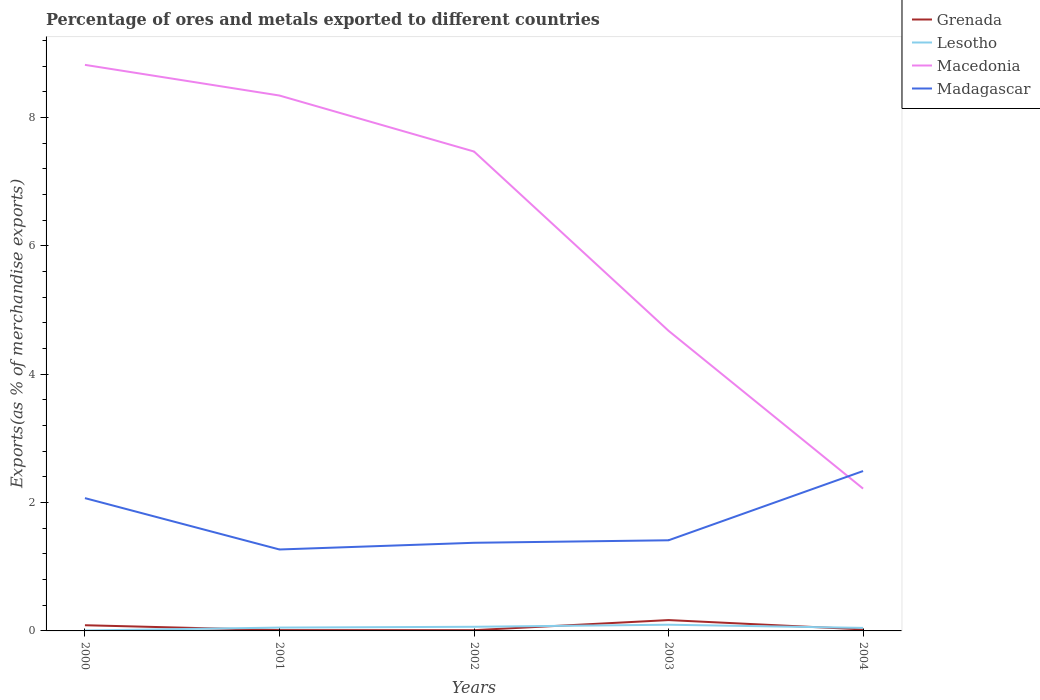How many different coloured lines are there?
Give a very brief answer. 4. Is the number of lines equal to the number of legend labels?
Your answer should be compact. Yes. Across all years, what is the maximum percentage of exports to different countries in Madagascar?
Make the answer very short. 1.27. In which year was the percentage of exports to different countries in Lesotho maximum?
Your answer should be very brief. 2000. What is the total percentage of exports to different countries in Madagascar in the graph?
Offer a very short reply. -1.12. What is the difference between the highest and the second highest percentage of exports to different countries in Grenada?
Your answer should be very brief. 0.16. What is the difference between the highest and the lowest percentage of exports to different countries in Grenada?
Your answer should be compact. 2. What is the difference between two consecutive major ticks on the Y-axis?
Make the answer very short. 2. Are the values on the major ticks of Y-axis written in scientific E-notation?
Keep it short and to the point. No. Does the graph contain any zero values?
Offer a terse response. No. Where does the legend appear in the graph?
Offer a terse response. Top right. How are the legend labels stacked?
Offer a terse response. Vertical. What is the title of the graph?
Give a very brief answer. Percentage of ores and metals exported to different countries. Does "Nicaragua" appear as one of the legend labels in the graph?
Make the answer very short. No. What is the label or title of the X-axis?
Provide a succinct answer. Years. What is the label or title of the Y-axis?
Your answer should be compact. Exports(as % of merchandise exports). What is the Exports(as % of merchandise exports) of Grenada in 2000?
Provide a succinct answer. 0.09. What is the Exports(as % of merchandise exports) of Lesotho in 2000?
Provide a succinct answer. 0.01. What is the Exports(as % of merchandise exports) of Macedonia in 2000?
Give a very brief answer. 8.82. What is the Exports(as % of merchandise exports) of Madagascar in 2000?
Provide a short and direct response. 2.07. What is the Exports(as % of merchandise exports) in Grenada in 2001?
Keep it short and to the point. 0.01. What is the Exports(as % of merchandise exports) in Lesotho in 2001?
Your response must be concise. 0.05. What is the Exports(as % of merchandise exports) in Macedonia in 2001?
Your answer should be compact. 8.34. What is the Exports(as % of merchandise exports) in Madagascar in 2001?
Provide a short and direct response. 1.27. What is the Exports(as % of merchandise exports) in Grenada in 2002?
Ensure brevity in your answer.  0.01. What is the Exports(as % of merchandise exports) in Lesotho in 2002?
Your answer should be very brief. 0.06. What is the Exports(as % of merchandise exports) in Macedonia in 2002?
Your response must be concise. 7.47. What is the Exports(as % of merchandise exports) in Madagascar in 2002?
Offer a terse response. 1.37. What is the Exports(as % of merchandise exports) of Grenada in 2003?
Your answer should be very brief. 0.17. What is the Exports(as % of merchandise exports) in Lesotho in 2003?
Your response must be concise. 0.1. What is the Exports(as % of merchandise exports) of Macedonia in 2003?
Provide a short and direct response. 4.68. What is the Exports(as % of merchandise exports) of Madagascar in 2003?
Ensure brevity in your answer.  1.41. What is the Exports(as % of merchandise exports) of Grenada in 2004?
Offer a terse response. 0.02. What is the Exports(as % of merchandise exports) in Lesotho in 2004?
Keep it short and to the point. 0.05. What is the Exports(as % of merchandise exports) of Macedonia in 2004?
Your answer should be very brief. 2.22. What is the Exports(as % of merchandise exports) in Madagascar in 2004?
Your answer should be very brief. 2.49. Across all years, what is the maximum Exports(as % of merchandise exports) of Grenada?
Make the answer very short. 0.17. Across all years, what is the maximum Exports(as % of merchandise exports) of Lesotho?
Give a very brief answer. 0.1. Across all years, what is the maximum Exports(as % of merchandise exports) of Macedonia?
Your response must be concise. 8.82. Across all years, what is the maximum Exports(as % of merchandise exports) of Madagascar?
Give a very brief answer. 2.49. Across all years, what is the minimum Exports(as % of merchandise exports) in Grenada?
Give a very brief answer. 0.01. Across all years, what is the minimum Exports(as % of merchandise exports) of Lesotho?
Give a very brief answer. 0.01. Across all years, what is the minimum Exports(as % of merchandise exports) in Macedonia?
Your response must be concise. 2.22. Across all years, what is the minimum Exports(as % of merchandise exports) in Madagascar?
Your answer should be very brief. 1.27. What is the total Exports(as % of merchandise exports) in Grenada in the graph?
Give a very brief answer. 0.31. What is the total Exports(as % of merchandise exports) in Lesotho in the graph?
Ensure brevity in your answer.  0.27. What is the total Exports(as % of merchandise exports) in Macedonia in the graph?
Give a very brief answer. 31.53. What is the total Exports(as % of merchandise exports) of Madagascar in the graph?
Your response must be concise. 8.61. What is the difference between the Exports(as % of merchandise exports) of Grenada in 2000 and that in 2001?
Provide a succinct answer. 0.08. What is the difference between the Exports(as % of merchandise exports) in Lesotho in 2000 and that in 2001?
Make the answer very short. -0.05. What is the difference between the Exports(as % of merchandise exports) in Macedonia in 2000 and that in 2001?
Your answer should be compact. 0.48. What is the difference between the Exports(as % of merchandise exports) of Madagascar in 2000 and that in 2001?
Keep it short and to the point. 0.8. What is the difference between the Exports(as % of merchandise exports) of Grenada in 2000 and that in 2002?
Your answer should be compact. 0.08. What is the difference between the Exports(as % of merchandise exports) in Lesotho in 2000 and that in 2002?
Ensure brevity in your answer.  -0.06. What is the difference between the Exports(as % of merchandise exports) of Macedonia in 2000 and that in 2002?
Give a very brief answer. 1.35. What is the difference between the Exports(as % of merchandise exports) in Madagascar in 2000 and that in 2002?
Provide a short and direct response. 0.7. What is the difference between the Exports(as % of merchandise exports) in Grenada in 2000 and that in 2003?
Provide a short and direct response. -0.08. What is the difference between the Exports(as % of merchandise exports) in Lesotho in 2000 and that in 2003?
Your answer should be very brief. -0.09. What is the difference between the Exports(as % of merchandise exports) of Macedonia in 2000 and that in 2003?
Give a very brief answer. 4.14. What is the difference between the Exports(as % of merchandise exports) in Madagascar in 2000 and that in 2003?
Your answer should be compact. 0.66. What is the difference between the Exports(as % of merchandise exports) of Grenada in 2000 and that in 2004?
Keep it short and to the point. 0.07. What is the difference between the Exports(as % of merchandise exports) in Lesotho in 2000 and that in 2004?
Ensure brevity in your answer.  -0.04. What is the difference between the Exports(as % of merchandise exports) of Macedonia in 2000 and that in 2004?
Make the answer very short. 6.6. What is the difference between the Exports(as % of merchandise exports) in Madagascar in 2000 and that in 2004?
Provide a short and direct response. -0.42. What is the difference between the Exports(as % of merchandise exports) in Grenada in 2001 and that in 2002?
Keep it short and to the point. 0. What is the difference between the Exports(as % of merchandise exports) in Lesotho in 2001 and that in 2002?
Offer a terse response. -0.01. What is the difference between the Exports(as % of merchandise exports) in Macedonia in 2001 and that in 2002?
Your response must be concise. 0.87. What is the difference between the Exports(as % of merchandise exports) of Madagascar in 2001 and that in 2002?
Provide a short and direct response. -0.1. What is the difference between the Exports(as % of merchandise exports) of Grenada in 2001 and that in 2003?
Offer a terse response. -0.16. What is the difference between the Exports(as % of merchandise exports) in Lesotho in 2001 and that in 2003?
Provide a short and direct response. -0.04. What is the difference between the Exports(as % of merchandise exports) of Macedonia in 2001 and that in 2003?
Your answer should be very brief. 3.67. What is the difference between the Exports(as % of merchandise exports) of Madagascar in 2001 and that in 2003?
Keep it short and to the point. -0.14. What is the difference between the Exports(as % of merchandise exports) of Grenada in 2001 and that in 2004?
Give a very brief answer. -0.01. What is the difference between the Exports(as % of merchandise exports) of Lesotho in 2001 and that in 2004?
Your answer should be very brief. 0. What is the difference between the Exports(as % of merchandise exports) in Macedonia in 2001 and that in 2004?
Your answer should be very brief. 6.12. What is the difference between the Exports(as % of merchandise exports) of Madagascar in 2001 and that in 2004?
Provide a succinct answer. -1.22. What is the difference between the Exports(as % of merchandise exports) of Grenada in 2002 and that in 2003?
Your answer should be compact. -0.16. What is the difference between the Exports(as % of merchandise exports) in Lesotho in 2002 and that in 2003?
Provide a succinct answer. -0.03. What is the difference between the Exports(as % of merchandise exports) in Macedonia in 2002 and that in 2003?
Your answer should be very brief. 2.79. What is the difference between the Exports(as % of merchandise exports) of Madagascar in 2002 and that in 2003?
Provide a short and direct response. -0.04. What is the difference between the Exports(as % of merchandise exports) in Grenada in 2002 and that in 2004?
Offer a terse response. -0.01. What is the difference between the Exports(as % of merchandise exports) in Lesotho in 2002 and that in 2004?
Your response must be concise. 0.02. What is the difference between the Exports(as % of merchandise exports) in Macedonia in 2002 and that in 2004?
Your response must be concise. 5.25. What is the difference between the Exports(as % of merchandise exports) of Madagascar in 2002 and that in 2004?
Offer a terse response. -1.12. What is the difference between the Exports(as % of merchandise exports) of Grenada in 2003 and that in 2004?
Your response must be concise. 0.15. What is the difference between the Exports(as % of merchandise exports) of Lesotho in 2003 and that in 2004?
Offer a terse response. 0.05. What is the difference between the Exports(as % of merchandise exports) of Macedonia in 2003 and that in 2004?
Make the answer very short. 2.46. What is the difference between the Exports(as % of merchandise exports) of Madagascar in 2003 and that in 2004?
Keep it short and to the point. -1.08. What is the difference between the Exports(as % of merchandise exports) in Grenada in 2000 and the Exports(as % of merchandise exports) in Lesotho in 2001?
Offer a terse response. 0.04. What is the difference between the Exports(as % of merchandise exports) in Grenada in 2000 and the Exports(as % of merchandise exports) in Macedonia in 2001?
Keep it short and to the point. -8.25. What is the difference between the Exports(as % of merchandise exports) in Grenada in 2000 and the Exports(as % of merchandise exports) in Madagascar in 2001?
Provide a succinct answer. -1.18. What is the difference between the Exports(as % of merchandise exports) of Lesotho in 2000 and the Exports(as % of merchandise exports) of Macedonia in 2001?
Offer a terse response. -8.34. What is the difference between the Exports(as % of merchandise exports) in Lesotho in 2000 and the Exports(as % of merchandise exports) in Madagascar in 2001?
Give a very brief answer. -1.26. What is the difference between the Exports(as % of merchandise exports) in Macedonia in 2000 and the Exports(as % of merchandise exports) in Madagascar in 2001?
Your response must be concise. 7.55. What is the difference between the Exports(as % of merchandise exports) in Grenada in 2000 and the Exports(as % of merchandise exports) in Lesotho in 2002?
Keep it short and to the point. 0.02. What is the difference between the Exports(as % of merchandise exports) of Grenada in 2000 and the Exports(as % of merchandise exports) of Macedonia in 2002?
Offer a very short reply. -7.38. What is the difference between the Exports(as % of merchandise exports) in Grenada in 2000 and the Exports(as % of merchandise exports) in Madagascar in 2002?
Provide a short and direct response. -1.28. What is the difference between the Exports(as % of merchandise exports) in Lesotho in 2000 and the Exports(as % of merchandise exports) in Macedonia in 2002?
Provide a succinct answer. -7.46. What is the difference between the Exports(as % of merchandise exports) in Lesotho in 2000 and the Exports(as % of merchandise exports) in Madagascar in 2002?
Your answer should be very brief. -1.37. What is the difference between the Exports(as % of merchandise exports) of Macedonia in 2000 and the Exports(as % of merchandise exports) of Madagascar in 2002?
Your answer should be very brief. 7.45. What is the difference between the Exports(as % of merchandise exports) of Grenada in 2000 and the Exports(as % of merchandise exports) of Lesotho in 2003?
Offer a very short reply. -0.01. What is the difference between the Exports(as % of merchandise exports) of Grenada in 2000 and the Exports(as % of merchandise exports) of Macedonia in 2003?
Give a very brief answer. -4.59. What is the difference between the Exports(as % of merchandise exports) in Grenada in 2000 and the Exports(as % of merchandise exports) in Madagascar in 2003?
Keep it short and to the point. -1.32. What is the difference between the Exports(as % of merchandise exports) of Lesotho in 2000 and the Exports(as % of merchandise exports) of Macedonia in 2003?
Provide a short and direct response. -4.67. What is the difference between the Exports(as % of merchandise exports) of Lesotho in 2000 and the Exports(as % of merchandise exports) of Madagascar in 2003?
Your answer should be very brief. -1.41. What is the difference between the Exports(as % of merchandise exports) of Macedonia in 2000 and the Exports(as % of merchandise exports) of Madagascar in 2003?
Offer a terse response. 7.41. What is the difference between the Exports(as % of merchandise exports) of Grenada in 2000 and the Exports(as % of merchandise exports) of Lesotho in 2004?
Offer a very short reply. 0.04. What is the difference between the Exports(as % of merchandise exports) of Grenada in 2000 and the Exports(as % of merchandise exports) of Macedonia in 2004?
Your answer should be very brief. -2.13. What is the difference between the Exports(as % of merchandise exports) of Grenada in 2000 and the Exports(as % of merchandise exports) of Madagascar in 2004?
Offer a terse response. -2.4. What is the difference between the Exports(as % of merchandise exports) in Lesotho in 2000 and the Exports(as % of merchandise exports) in Macedonia in 2004?
Provide a succinct answer. -2.21. What is the difference between the Exports(as % of merchandise exports) in Lesotho in 2000 and the Exports(as % of merchandise exports) in Madagascar in 2004?
Provide a succinct answer. -2.48. What is the difference between the Exports(as % of merchandise exports) of Macedonia in 2000 and the Exports(as % of merchandise exports) of Madagascar in 2004?
Offer a terse response. 6.33. What is the difference between the Exports(as % of merchandise exports) in Grenada in 2001 and the Exports(as % of merchandise exports) in Lesotho in 2002?
Give a very brief answer. -0.05. What is the difference between the Exports(as % of merchandise exports) in Grenada in 2001 and the Exports(as % of merchandise exports) in Macedonia in 2002?
Keep it short and to the point. -7.46. What is the difference between the Exports(as % of merchandise exports) of Grenada in 2001 and the Exports(as % of merchandise exports) of Madagascar in 2002?
Keep it short and to the point. -1.36. What is the difference between the Exports(as % of merchandise exports) in Lesotho in 2001 and the Exports(as % of merchandise exports) in Macedonia in 2002?
Keep it short and to the point. -7.42. What is the difference between the Exports(as % of merchandise exports) of Lesotho in 2001 and the Exports(as % of merchandise exports) of Madagascar in 2002?
Ensure brevity in your answer.  -1.32. What is the difference between the Exports(as % of merchandise exports) in Macedonia in 2001 and the Exports(as % of merchandise exports) in Madagascar in 2002?
Ensure brevity in your answer.  6.97. What is the difference between the Exports(as % of merchandise exports) of Grenada in 2001 and the Exports(as % of merchandise exports) of Lesotho in 2003?
Your answer should be very brief. -0.08. What is the difference between the Exports(as % of merchandise exports) in Grenada in 2001 and the Exports(as % of merchandise exports) in Macedonia in 2003?
Give a very brief answer. -4.66. What is the difference between the Exports(as % of merchandise exports) in Grenada in 2001 and the Exports(as % of merchandise exports) in Madagascar in 2003?
Keep it short and to the point. -1.4. What is the difference between the Exports(as % of merchandise exports) in Lesotho in 2001 and the Exports(as % of merchandise exports) in Macedonia in 2003?
Offer a terse response. -4.62. What is the difference between the Exports(as % of merchandise exports) in Lesotho in 2001 and the Exports(as % of merchandise exports) in Madagascar in 2003?
Provide a succinct answer. -1.36. What is the difference between the Exports(as % of merchandise exports) in Macedonia in 2001 and the Exports(as % of merchandise exports) in Madagascar in 2003?
Make the answer very short. 6.93. What is the difference between the Exports(as % of merchandise exports) in Grenada in 2001 and the Exports(as % of merchandise exports) in Lesotho in 2004?
Provide a short and direct response. -0.03. What is the difference between the Exports(as % of merchandise exports) in Grenada in 2001 and the Exports(as % of merchandise exports) in Macedonia in 2004?
Provide a short and direct response. -2.2. What is the difference between the Exports(as % of merchandise exports) of Grenada in 2001 and the Exports(as % of merchandise exports) of Madagascar in 2004?
Provide a succinct answer. -2.48. What is the difference between the Exports(as % of merchandise exports) in Lesotho in 2001 and the Exports(as % of merchandise exports) in Macedonia in 2004?
Give a very brief answer. -2.17. What is the difference between the Exports(as % of merchandise exports) in Lesotho in 2001 and the Exports(as % of merchandise exports) in Madagascar in 2004?
Provide a succinct answer. -2.44. What is the difference between the Exports(as % of merchandise exports) in Macedonia in 2001 and the Exports(as % of merchandise exports) in Madagascar in 2004?
Your answer should be very brief. 5.85. What is the difference between the Exports(as % of merchandise exports) of Grenada in 2002 and the Exports(as % of merchandise exports) of Lesotho in 2003?
Your response must be concise. -0.09. What is the difference between the Exports(as % of merchandise exports) of Grenada in 2002 and the Exports(as % of merchandise exports) of Macedonia in 2003?
Offer a very short reply. -4.67. What is the difference between the Exports(as % of merchandise exports) in Grenada in 2002 and the Exports(as % of merchandise exports) in Madagascar in 2003?
Your response must be concise. -1.4. What is the difference between the Exports(as % of merchandise exports) of Lesotho in 2002 and the Exports(as % of merchandise exports) of Macedonia in 2003?
Make the answer very short. -4.61. What is the difference between the Exports(as % of merchandise exports) of Lesotho in 2002 and the Exports(as % of merchandise exports) of Madagascar in 2003?
Provide a short and direct response. -1.35. What is the difference between the Exports(as % of merchandise exports) of Macedonia in 2002 and the Exports(as % of merchandise exports) of Madagascar in 2003?
Your answer should be compact. 6.06. What is the difference between the Exports(as % of merchandise exports) in Grenada in 2002 and the Exports(as % of merchandise exports) in Lesotho in 2004?
Your answer should be compact. -0.04. What is the difference between the Exports(as % of merchandise exports) in Grenada in 2002 and the Exports(as % of merchandise exports) in Macedonia in 2004?
Provide a succinct answer. -2.21. What is the difference between the Exports(as % of merchandise exports) of Grenada in 2002 and the Exports(as % of merchandise exports) of Madagascar in 2004?
Your response must be concise. -2.48. What is the difference between the Exports(as % of merchandise exports) in Lesotho in 2002 and the Exports(as % of merchandise exports) in Macedonia in 2004?
Make the answer very short. -2.15. What is the difference between the Exports(as % of merchandise exports) of Lesotho in 2002 and the Exports(as % of merchandise exports) of Madagascar in 2004?
Make the answer very short. -2.43. What is the difference between the Exports(as % of merchandise exports) in Macedonia in 2002 and the Exports(as % of merchandise exports) in Madagascar in 2004?
Ensure brevity in your answer.  4.98. What is the difference between the Exports(as % of merchandise exports) in Grenada in 2003 and the Exports(as % of merchandise exports) in Lesotho in 2004?
Your response must be concise. 0.12. What is the difference between the Exports(as % of merchandise exports) in Grenada in 2003 and the Exports(as % of merchandise exports) in Macedonia in 2004?
Provide a succinct answer. -2.05. What is the difference between the Exports(as % of merchandise exports) in Grenada in 2003 and the Exports(as % of merchandise exports) in Madagascar in 2004?
Make the answer very short. -2.32. What is the difference between the Exports(as % of merchandise exports) of Lesotho in 2003 and the Exports(as % of merchandise exports) of Macedonia in 2004?
Your answer should be very brief. -2.12. What is the difference between the Exports(as % of merchandise exports) in Lesotho in 2003 and the Exports(as % of merchandise exports) in Madagascar in 2004?
Offer a terse response. -2.39. What is the difference between the Exports(as % of merchandise exports) in Macedonia in 2003 and the Exports(as % of merchandise exports) in Madagascar in 2004?
Offer a terse response. 2.19. What is the average Exports(as % of merchandise exports) of Grenada per year?
Your answer should be compact. 0.06. What is the average Exports(as % of merchandise exports) of Lesotho per year?
Keep it short and to the point. 0.05. What is the average Exports(as % of merchandise exports) of Macedonia per year?
Your answer should be compact. 6.31. What is the average Exports(as % of merchandise exports) of Madagascar per year?
Make the answer very short. 1.72. In the year 2000, what is the difference between the Exports(as % of merchandise exports) of Grenada and Exports(as % of merchandise exports) of Lesotho?
Ensure brevity in your answer.  0.08. In the year 2000, what is the difference between the Exports(as % of merchandise exports) of Grenada and Exports(as % of merchandise exports) of Macedonia?
Your response must be concise. -8.73. In the year 2000, what is the difference between the Exports(as % of merchandise exports) of Grenada and Exports(as % of merchandise exports) of Madagascar?
Your answer should be very brief. -1.98. In the year 2000, what is the difference between the Exports(as % of merchandise exports) of Lesotho and Exports(as % of merchandise exports) of Macedonia?
Ensure brevity in your answer.  -8.81. In the year 2000, what is the difference between the Exports(as % of merchandise exports) of Lesotho and Exports(as % of merchandise exports) of Madagascar?
Offer a very short reply. -2.06. In the year 2000, what is the difference between the Exports(as % of merchandise exports) in Macedonia and Exports(as % of merchandise exports) in Madagascar?
Keep it short and to the point. 6.75. In the year 2001, what is the difference between the Exports(as % of merchandise exports) of Grenada and Exports(as % of merchandise exports) of Lesotho?
Your response must be concise. -0.04. In the year 2001, what is the difference between the Exports(as % of merchandise exports) of Grenada and Exports(as % of merchandise exports) of Macedonia?
Offer a terse response. -8.33. In the year 2001, what is the difference between the Exports(as % of merchandise exports) in Grenada and Exports(as % of merchandise exports) in Madagascar?
Give a very brief answer. -1.26. In the year 2001, what is the difference between the Exports(as % of merchandise exports) in Lesotho and Exports(as % of merchandise exports) in Macedonia?
Ensure brevity in your answer.  -8.29. In the year 2001, what is the difference between the Exports(as % of merchandise exports) of Lesotho and Exports(as % of merchandise exports) of Madagascar?
Provide a succinct answer. -1.22. In the year 2001, what is the difference between the Exports(as % of merchandise exports) of Macedonia and Exports(as % of merchandise exports) of Madagascar?
Provide a short and direct response. 7.07. In the year 2002, what is the difference between the Exports(as % of merchandise exports) in Grenada and Exports(as % of merchandise exports) in Lesotho?
Offer a very short reply. -0.05. In the year 2002, what is the difference between the Exports(as % of merchandise exports) in Grenada and Exports(as % of merchandise exports) in Macedonia?
Provide a succinct answer. -7.46. In the year 2002, what is the difference between the Exports(as % of merchandise exports) of Grenada and Exports(as % of merchandise exports) of Madagascar?
Give a very brief answer. -1.36. In the year 2002, what is the difference between the Exports(as % of merchandise exports) in Lesotho and Exports(as % of merchandise exports) in Macedonia?
Your answer should be very brief. -7.41. In the year 2002, what is the difference between the Exports(as % of merchandise exports) in Lesotho and Exports(as % of merchandise exports) in Madagascar?
Keep it short and to the point. -1.31. In the year 2002, what is the difference between the Exports(as % of merchandise exports) of Macedonia and Exports(as % of merchandise exports) of Madagascar?
Offer a terse response. 6.1. In the year 2003, what is the difference between the Exports(as % of merchandise exports) of Grenada and Exports(as % of merchandise exports) of Lesotho?
Provide a succinct answer. 0.07. In the year 2003, what is the difference between the Exports(as % of merchandise exports) of Grenada and Exports(as % of merchandise exports) of Macedonia?
Make the answer very short. -4.51. In the year 2003, what is the difference between the Exports(as % of merchandise exports) of Grenada and Exports(as % of merchandise exports) of Madagascar?
Make the answer very short. -1.24. In the year 2003, what is the difference between the Exports(as % of merchandise exports) in Lesotho and Exports(as % of merchandise exports) in Macedonia?
Provide a succinct answer. -4.58. In the year 2003, what is the difference between the Exports(as % of merchandise exports) of Lesotho and Exports(as % of merchandise exports) of Madagascar?
Your answer should be very brief. -1.32. In the year 2003, what is the difference between the Exports(as % of merchandise exports) in Macedonia and Exports(as % of merchandise exports) in Madagascar?
Ensure brevity in your answer.  3.26. In the year 2004, what is the difference between the Exports(as % of merchandise exports) in Grenada and Exports(as % of merchandise exports) in Lesotho?
Provide a short and direct response. -0.02. In the year 2004, what is the difference between the Exports(as % of merchandise exports) in Grenada and Exports(as % of merchandise exports) in Macedonia?
Make the answer very short. -2.19. In the year 2004, what is the difference between the Exports(as % of merchandise exports) of Grenada and Exports(as % of merchandise exports) of Madagascar?
Give a very brief answer. -2.47. In the year 2004, what is the difference between the Exports(as % of merchandise exports) in Lesotho and Exports(as % of merchandise exports) in Macedonia?
Offer a very short reply. -2.17. In the year 2004, what is the difference between the Exports(as % of merchandise exports) in Lesotho and Exports(as % of merchandise exports) in Madagascar?
Make the answer very short. -2.44. In the year 2004, what is the difference between the Exports(as % of merchandise exports) in Macedonia and Exports(as % of merchandise exports) in Madagascar?
Give a very brief answer. -0.27. What is the ratio of the Exports(as % of merchandise exports) in Grenada in 2000 to that in 2001?
Make the answer very short. 6.9. What is the ratio of the Exports(as % of merchandise exports) of Lesotho in 2000 to that in 2001?
Your answer should be compact. 0.13. What is the ratio of the Exports(as % of merchandise exports) of Macedonia in 2000 to that in 2001?
Your response must be concise. 1.06. What is the ratio of the Exports(as % of merchandise exports) in Madagascar in 2000 to that in 2001?
Offer a terse response. 1.63. What is the ratio of the Exports(as % of merchandise exports) in Grenada in 2000 to that in 2002?
Provide a short and direct response. 7.65. What is the ratio of the Exports(as % of merchandise exports) of Lesotho in 2000 to that in 2002?
Keep it short and to the point. 0.11. What is the ratio of the Exports(as % of merchandise exports) in Macedonia in 2000 to that in 2002?
Your response must be concise. 1.18. What is the ratio of the Exports(as % of merchandise exports) of Madagascar in 2000 to that in 2002?
Your response must be concise. 1.51. What is the ratio of the Exports(as % of merchandise exports) in Grenada in 2000 to that in 2003?
Give a very brief answer. 0.52. What is the ratio of the Exports(as % of merchandise exports) of Lesotho in 2000 to that in 2003?
Keep it short and to the point. 0.07. What is the ratio of the Exports(as % of merchandise exports) in Macedonia in 2000 to that in 2003?
Provide a succinct answer. 1.89. What is the ratio of the Exports(as % of merchandise exports) of Madagascar in 2000 to that in 2003?
Offer a terse response. 1.47. What is the ratio of the Exports(as % of merchandise exports) in Grenada in 2000 to that in 2004?
Provide a succinct answer. 3.75. What is the ratio of the Exports(as % of merchandise exports) of Lesotho in 2000 to that in 2004?
Your answer should be very brief. 0.15. What is the ratio of the Exports(as % of merchandise exports) in Macedonia in 2000 to that in 2004?
Provide a short and direct response. 3.98. What is the ratio of the Exports(as % of merchandise exports) in Madagascar in 2000 to that in 2004?
Provide a succinct answer. 0.83. What is the ratio of the Exports(as % of merchandise exports) of Grenada in 2001 to that in 2002?
Make the answer very short. 1.11. What is the ratio of the Exports(as % of merchandise exports) in Lesotho in 2001 to that in 2002?
Make the answer very short. 0.81. What is the ratio of the Exports(as % of merchandise exports) in Macedonia in 2001 to that in 2002?
Keep it short and to the point. 1.12. What is the ratio of the Exports(as % of merchandise exports) of Madagascar in 2001 to that in 2002?
Provide a short and direct response. 0.92. What is the ratio of the Exports(as % of merchandise exports) in Grenada in 2001 to that in 2003?
Your response must be concise. 0.08. What is the ratio of the Exports(as % of merchandise exports) in Lesotho in 2001 to that in 2003?
Make the answer very short. 0.54. What is the ratio of the Exports(as % of merchandise exports) of Macedonia in 2001 to that in 2003?
Your answer should be compact. 1.78. What is the ratio of the Exports(as % of merchandise exports) of Madagascar in 2001 to that in 2003?
Ensure brevity in your answer.  0.9. What is the ratio of the Exports(as % of merchandise exports) of Grenada in 2001 to that in 2004?
Offer a very short reply. 0.54. What is the ratio of the Exports(as % of merchandise exports) of Lesotho in 2001 to that in 2004?
Your answer should be very brief. 1.1. What is the ratio of the Exports(as % of merchandise exports) in Macedonia in 2001 to that in 2004?
Make the answer very short. 3.76. What is the ratio of the Exports(as % of merchandise exports) in Madagascar in 2001 to that in 2004?
Offer a terse response. 0.51. What is the ratio of the Exports(as % of merchandise exports) in Grenada in 2002 to that in 2003?
Ensure brevity in your answer.  0.07. What is the ratio of the Exports(as % of merchandise exports) of Lesotho in 2002 to that in 2003?
Offer a very short reply. 0.67. What is the ratio of the Exports(as % of merchandise exports) in Macedonia in 2002 to that in 2003?
Your response must be concise. 1.6. What is the ratio of the Exports(as % of merchandise exports) of Madagascar in 2002 to that in 2003?
Keep it short and to the point. 0.97. What is the ratio of the Exports(as % of merchandise exports) of Grenada in 2002 to that in 2004?
Provide a succinct answer. 0.49. What is the ratio of the Exports(as % of merchandise exports) of Lesotho in 2002 to that in 2004?
Your answer should be compact. 1.36. What is the ratio of the Exports(as % of merchandise exports) in Macedonia in 2002 to that in 2004?
Your answer should be compact. 3.37. What is the ratio of the Exports(as % of merchandise exports) in Madagascar in 2002 to that in 2004?
Offer a very short reply. 0.55. What is the ratio of the Exports(as % of merchandise exports) of Grenada in 2003 to that in 2004?
Make the answer very short. 7.15. What is the ratio of the Exports(as % of merchandise exports) of Lesotho in 2003 to that in 2004?
Provide a short and direct response. 2.05. What is the ratio of the Exports(as % of merchandise exports) in Macedonia in 2003 to that in 2004?
Offer a very short reply. 2.11. What is the ratio of the Exports(as % of merchandise exports) in Madagascar in 2003 to that in 2004?
Give a very brief answer. 0.57. What is the difference between the highest and the second highest Exports(as % of merchandise exports) of Grenada?
Make the answer very short. 0.08. What is the difference between the highest and the second highest Exports(as % of merchandise exports) in Lesotho?
Offer a terse response. 0.03. What is the difference between the highest and the second highest Exports(as % of merchandise exports) in Macedonia?
Make the answer very short. 0.48. What is the difference between the highest and the second highest Exports(as % of merchandise exports) in Madagascar?
Keep it short and to the point. 0.42. What is the difference between the highest and the lowest Exports(as % of merchandise exports) in Grenada?
Keep it short and to the point. 0.16. What is the difference between the highest and the lowest Exports(as % of merchandise exports) of Lesotho?
Your answer should be compact. 0.09. What is the difference between the highest and the lowest Exports(as % of merchandise exports) of Macedonia?
Offer a terse response. 6.6. What is the difference between the highest and the lowest Exports(as % of merchandise exports) of Madagascar?
Keep it short and to the point. 1.22. 